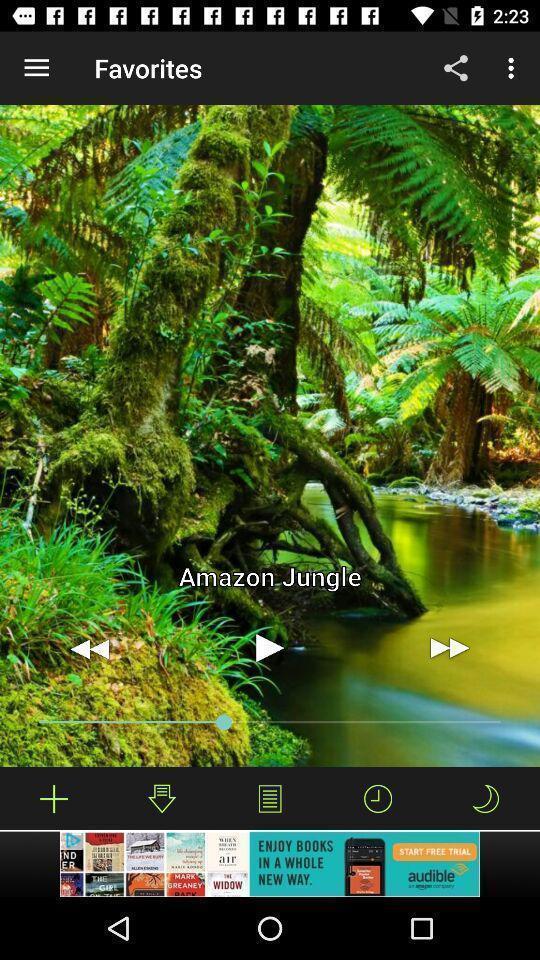Explain the elements present in this screenshot. Page showing video option on app. 